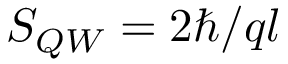Convert formula to latex. <formula><loc_0><loc_0><loc_500><loc_500>S _ { Q W } = 2 \hbar { / } q l</formula> 